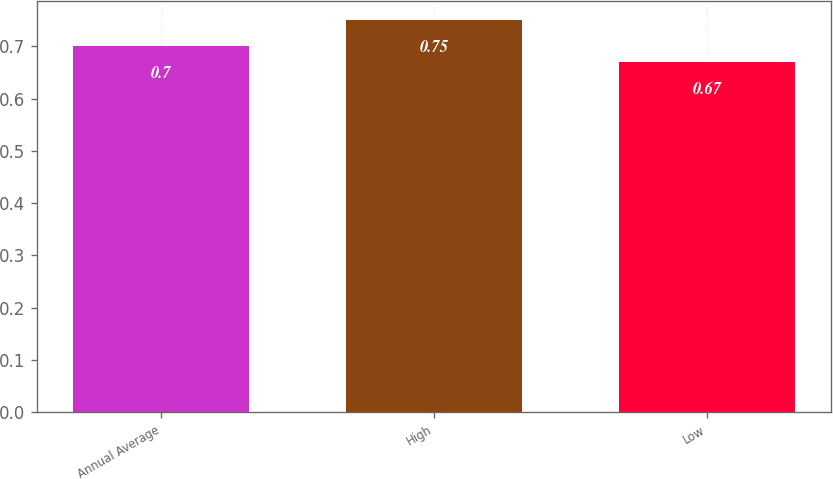Convert chart to OTSL. <chart><loc_0><loc_0><loc_500><loc_500><bar_chart><fcel>Annual Average<fcel>High<fcel>Low<nl><fcel>0.7<fcel>0.75<fcel>0.67<nl></chart> 